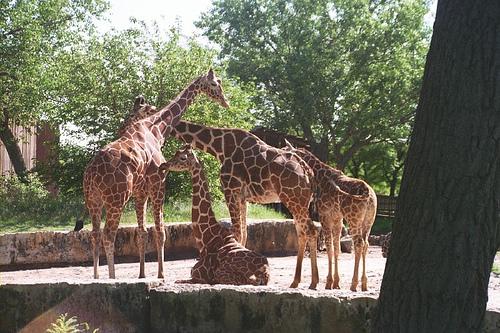Is there a tree blocking your view?
Short answer required. No. Do these giraffes live in the African grasslands?
Short answer required. Yes. How many giraffes are there?
Be succinct. 4. How many legs total do these animals have combined?
Short answer required. 16. 